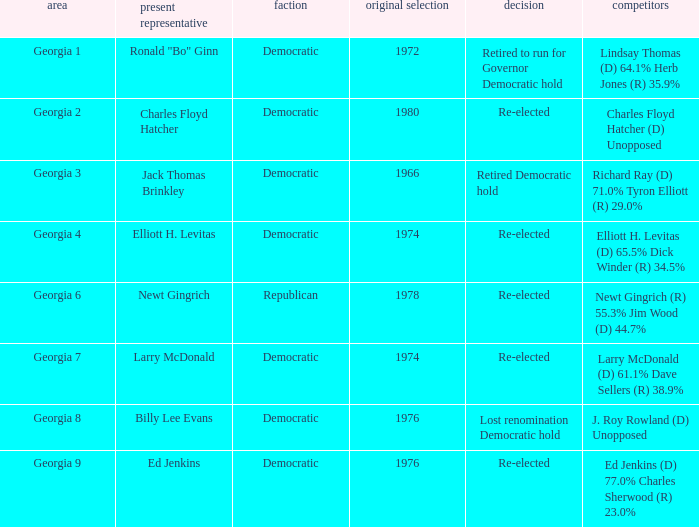Name the party of georgia 4 Democratic. 